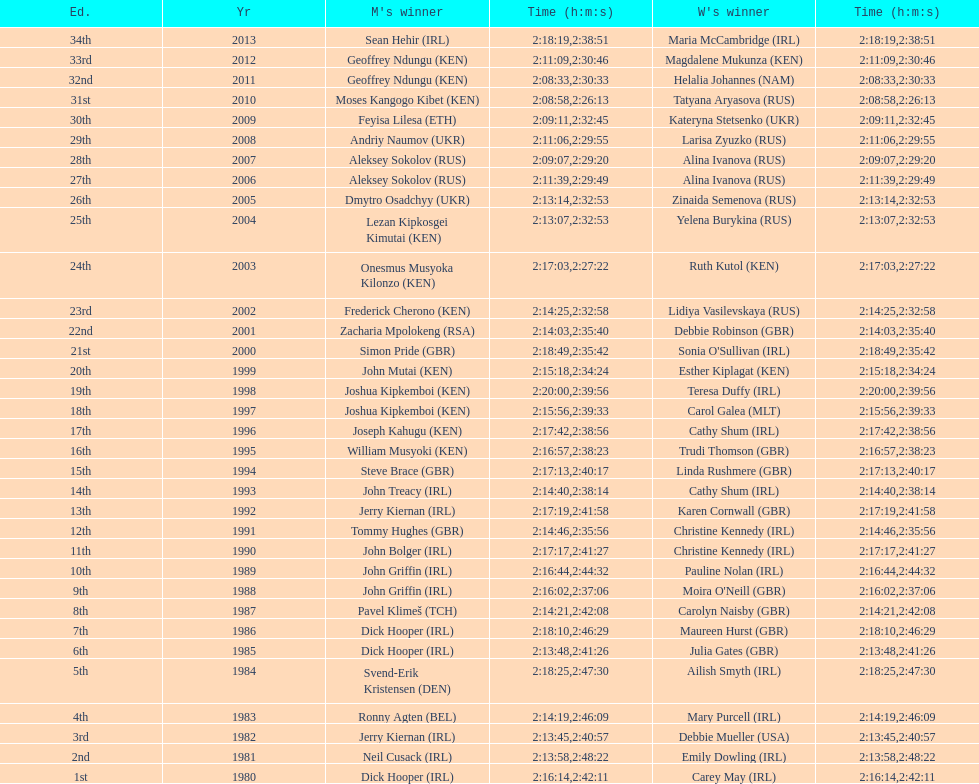Who won at least 3 times in the mens? Dick Hooper (IRL). 